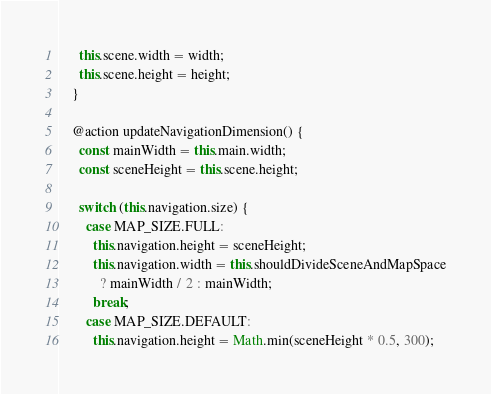Convert code to text. <code><loc_0><loc_0><loc_500><loc_500><_JavaScript_>
      this.scene.width = width;
      this.scene.height = height;
    }

    @action updateNavigationDimension() {
      const mainWidth = this.main.width;
      const sceneHeight = this.scene.height;

      switch (this.navigation.size) {
        case MAP_SIZE.FULL:
          this.navigation.height = sceneHeight;
          this.navigation.width = this.shouldDivideSceneAndMapSpace
            ? mainWidth / 2 : mainWidth;
          break;
        case MAP_SIZE.DEFAULT:
          this.navigation.height = Math.min(sceneHeight * 0.5, 300);</code> 